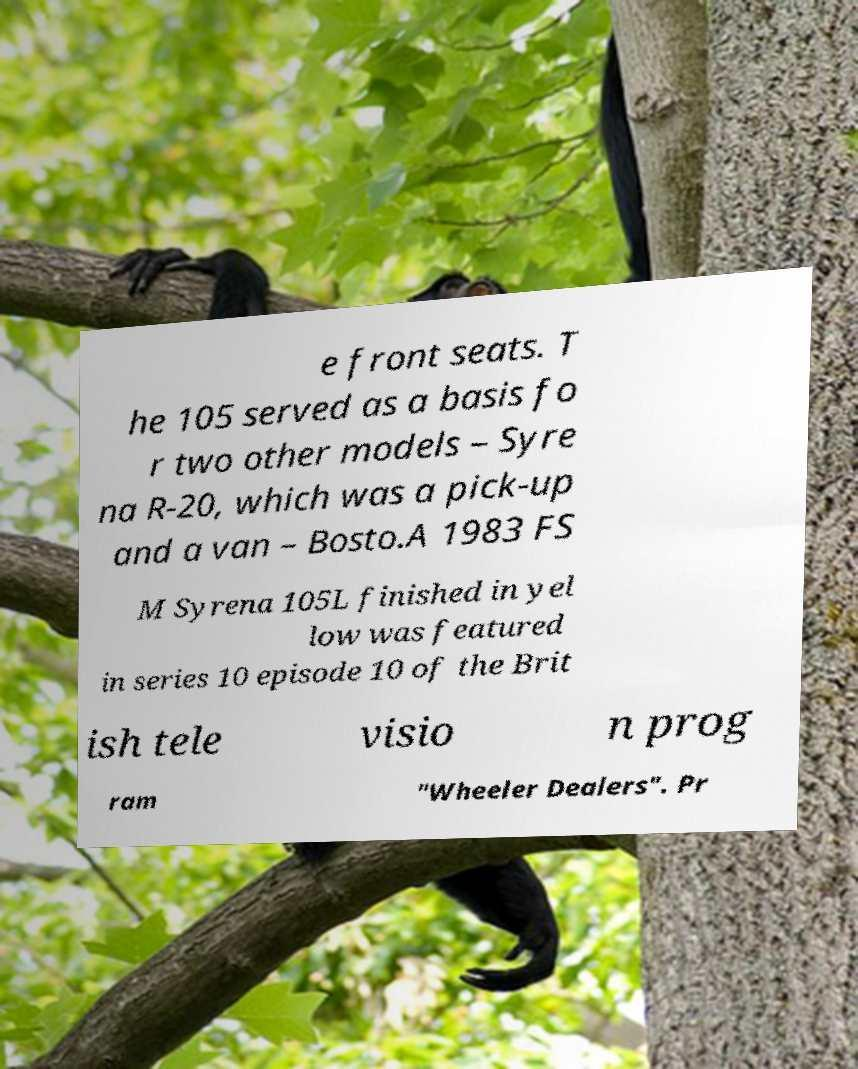For documentation purposes, I need the text within this image transcribed. Could you provide that? e front seats. T he 105 served as a basis fo r two other models – Syre na R-20, which was a pick-up and a van – Bosto.A 1983 FS M Syrena 105L finished in yel low was featured in series 10 episode 10 of the Brit ish tele visio n prog ram "Wheeler Dealers". Pr 